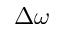Convert formula to latex. <formula><loc_0><loc_0><loc_500><loc_500>\Delta \omega</formula> 